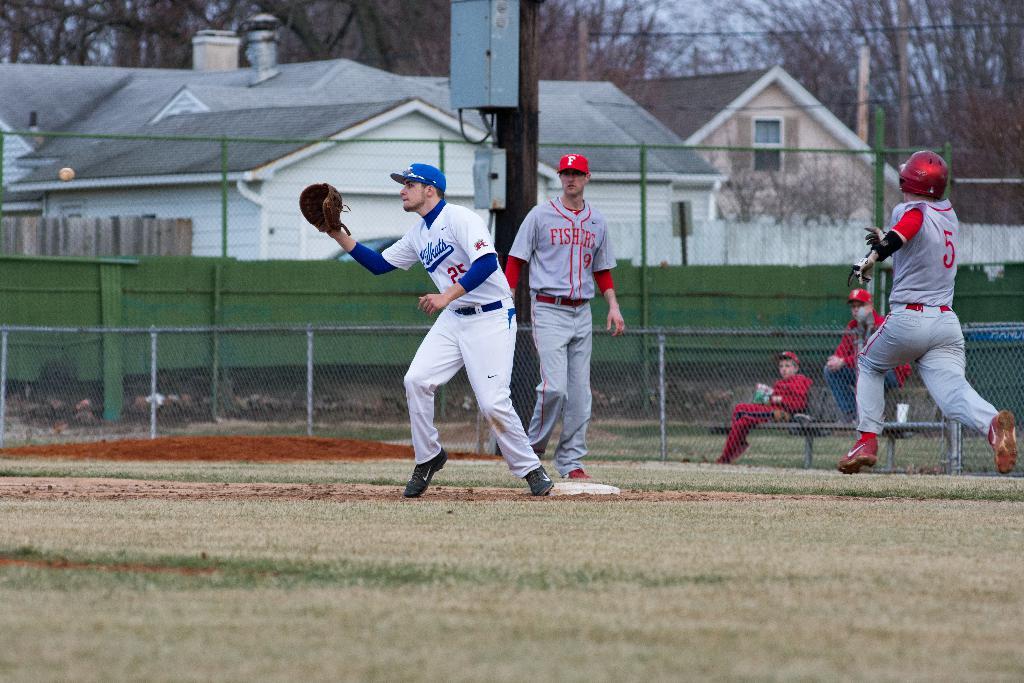What is the name of the red team?
Ensure brevity in your answer.  Fishers. What number is on the back of the white jersey on the right?
Make the answer very short. 5. 